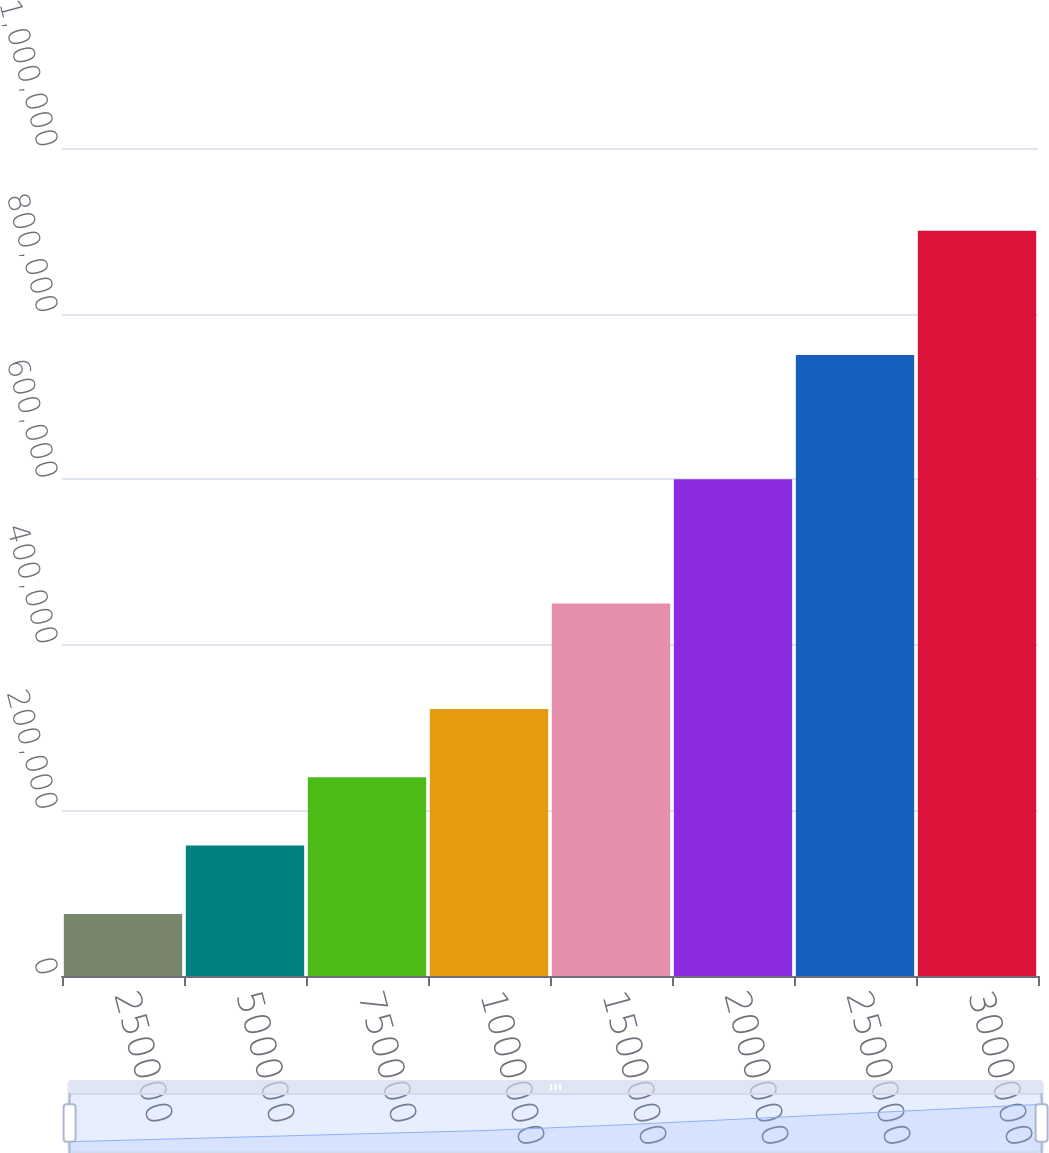<chart> <loc_0><loc_0><loc_500><loc_500><bar_chart><fcel>250000<fcel>500000<fcel>750000<fcel>1000000<fcel>1500000<fcel>2000000<fcel>2500000<fcel>3000000<nl><fcel>75000<fcel>157500<fcel>240000<fcel>322500<fcel>450000<fcel>600000<fcel>750000<fcel>900000<nl></chart> 